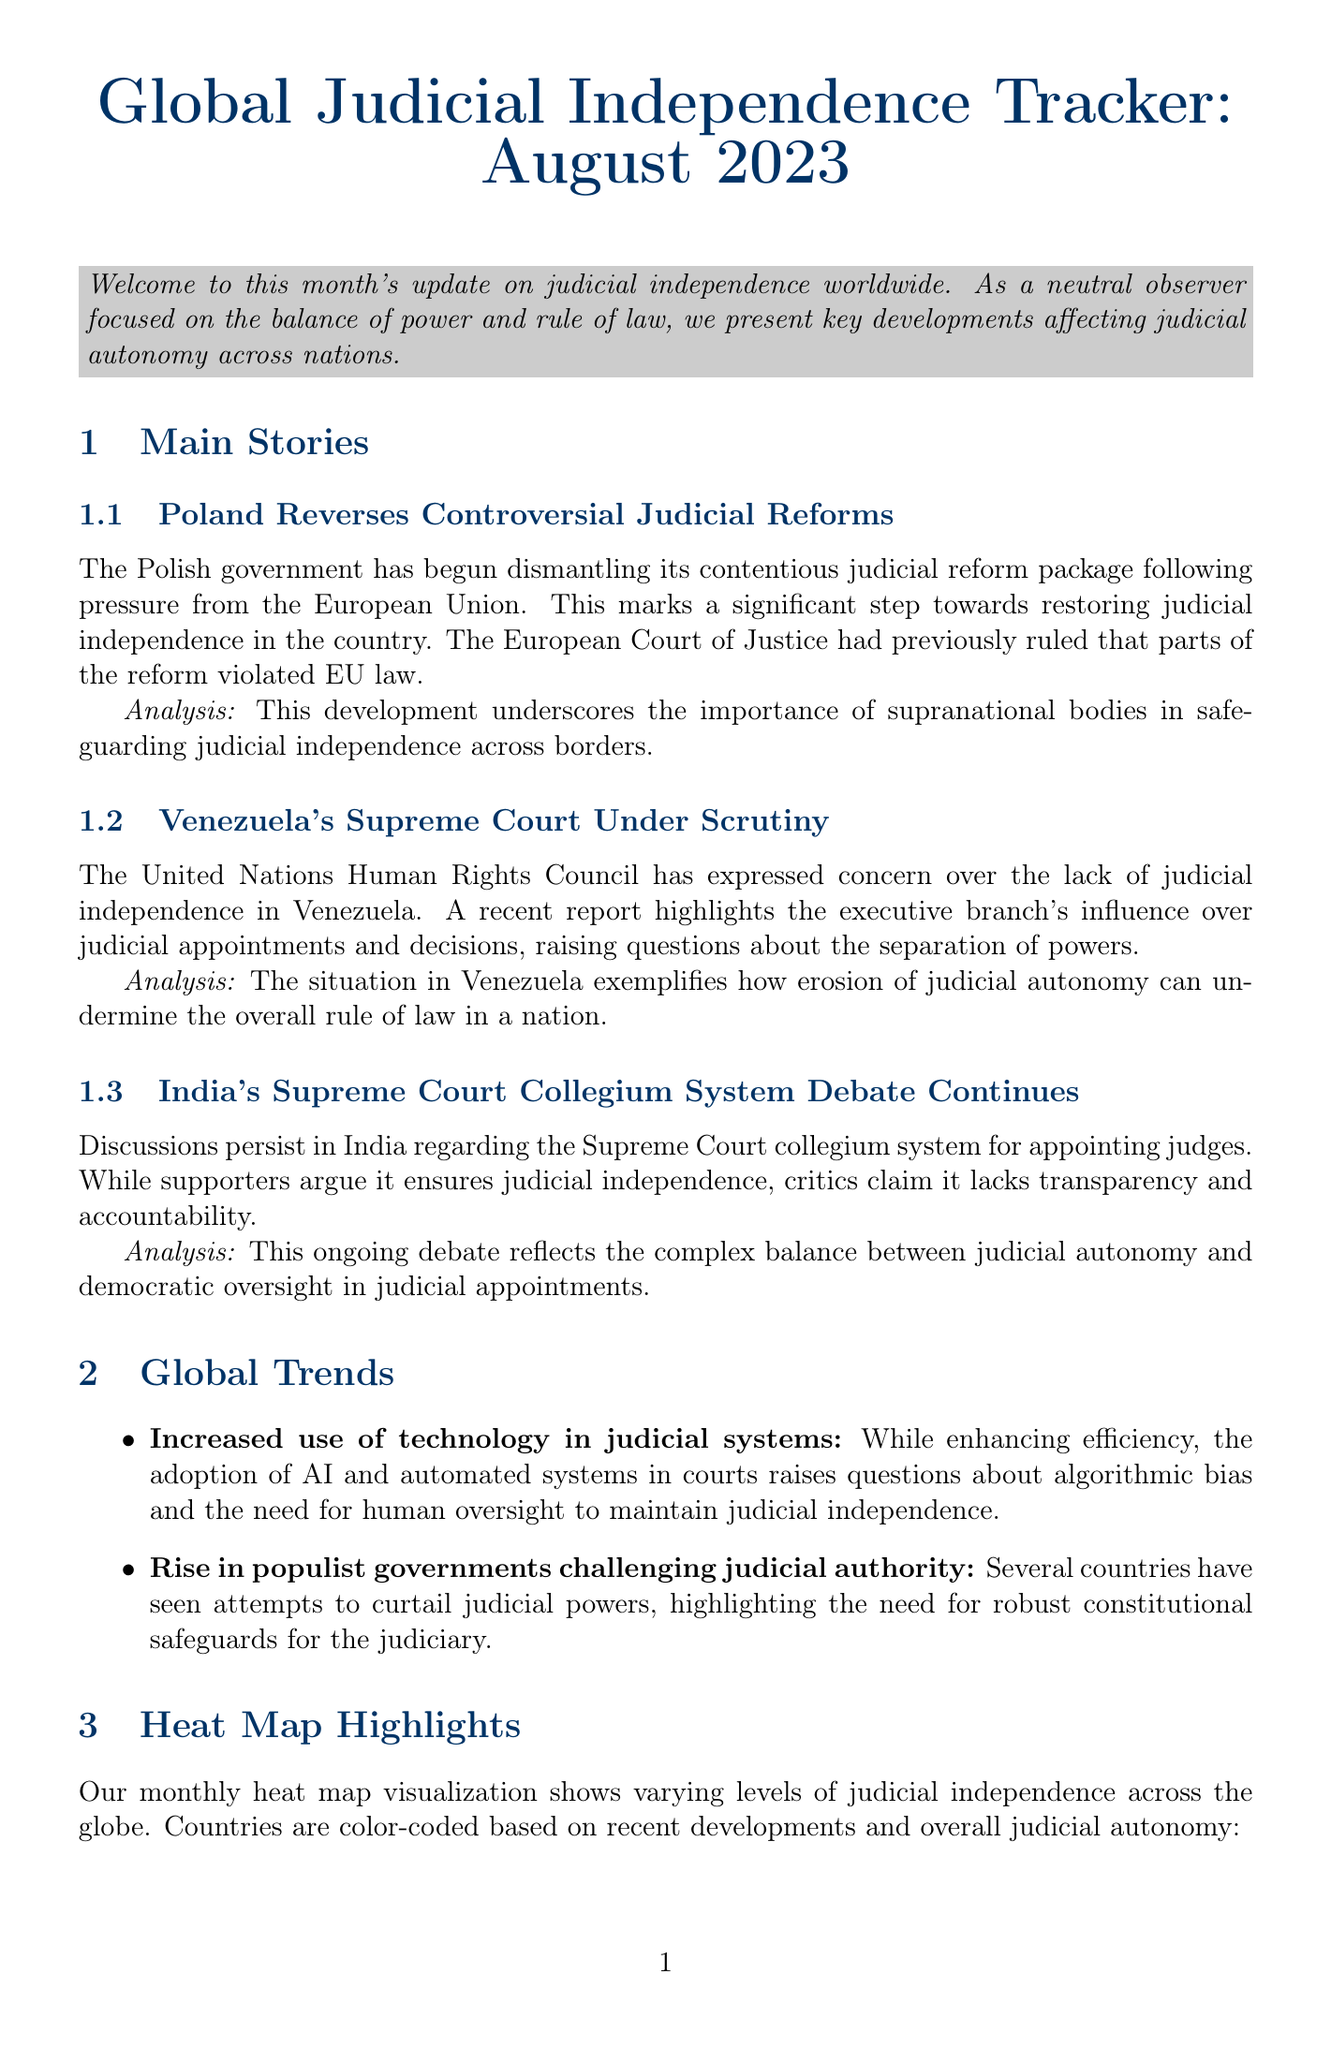What is the title of the newsletter? The title of the newsletter is explicitly stated at the beginning of the document.
Answer: Global Judicial Independence Tracker: August 2023 Which country is recognized for improving its judicial independence? The document highlights South Africa as a country where judicial independence is improving.
Answer: South Africa What significant step did Poland take regarding its judicial reforms? The content discusses Poland dismantling its judicial reform package as a response to EU pressure.
Answer: Reverses Controversial Judicial Reforms Who provided the expert opinion featured in the newsletter? The document specifically names Dr. Maria Rodriguez as the source of the expert opinion.
Answer: Dr. Maria Rodriguez What upcoming event is scheduled for September 2023? The document lists an upcoming event related to judicial independence in The Hague during September.
Answer: International Conference on Judicial Independence What trend involves the rise of populist governments? The document describes a global trend of challenges to judicial authority by populist governments.
Answer: Rise in populist governments challenging judicial authority How does the United Nations Human Rights Council view Venezuela's Supreme Court? The document mentions the UN Human Rights Council expressing concern over Venezuela's judicial independence.
Answer: Under Scrutiny What is the heat map intended to show? The heat map is designed to convey varying levels of judicial independence across different countries.
Answer: Varying levels of judicial independence 